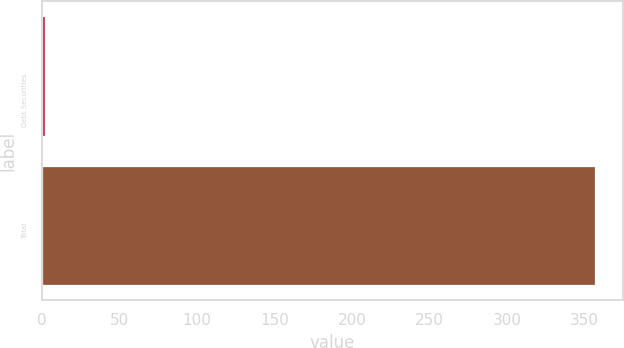Convert chart. <chart><loc_0><loc_0><loc_500><loc_500><bar_chart><fcel>Debt Securities<fcel>Total<nl><fcel>2.1<fcel>357<nl></chart> 